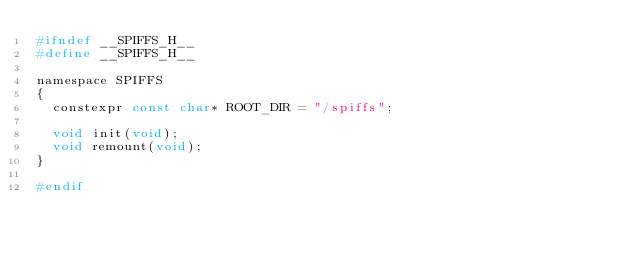Convert code to text. <code><loc_0><loc_0><loc_500><loc_500><_C_>#ifndef __SPIFFS_H__
#define __SPIFFS_H__

namespace SPIFFS
{
  constexpr const char* ROOT_DIR = "/spiffs";

  void init(void);
  void remount(void);
}

#endif</code> 